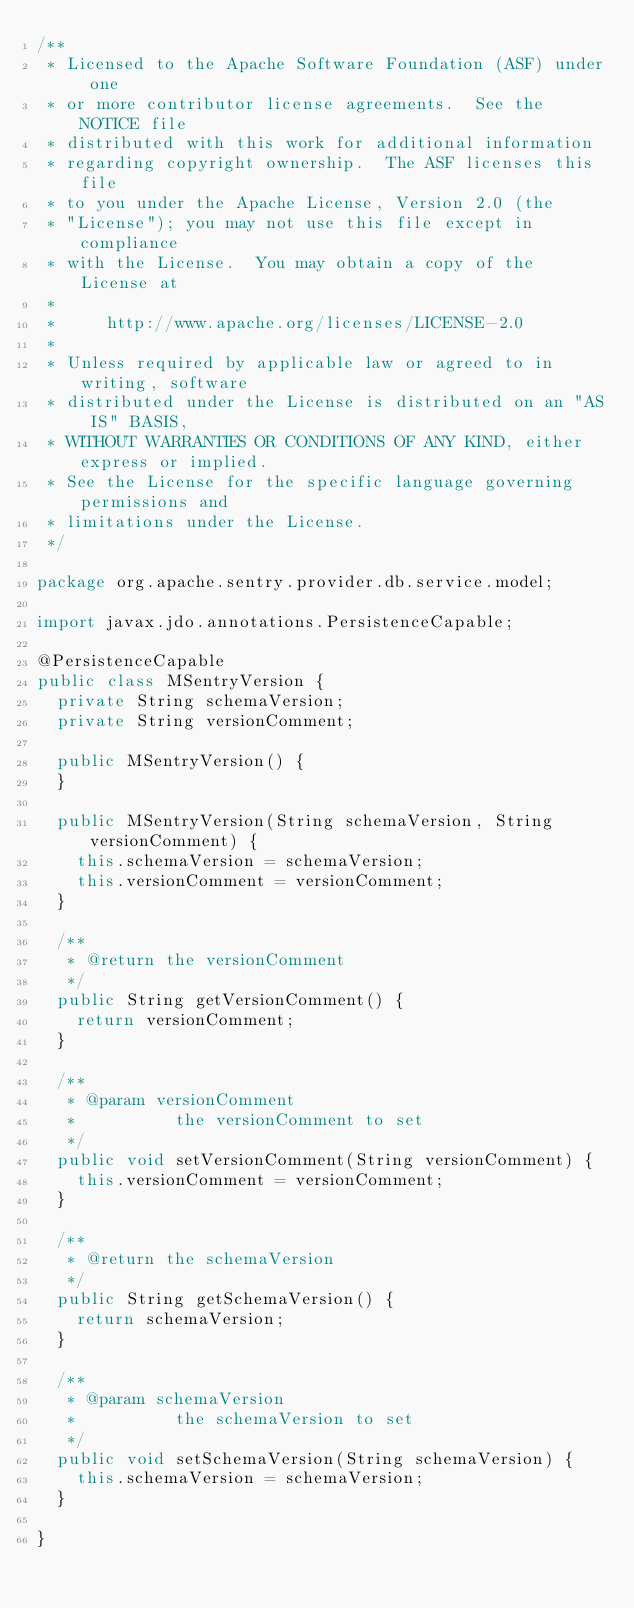<code> <loc_0><loc_0><loc_500><loc_500><_Java_>/**
 * Licensed to the Apache Software Foundation (ASF) under one
 * or more contributor license agreements.  See the NOTICE file
 * distributed with this work for additional information
 * regarding copyright ownership.  The ASF licenses this file
 * to you under the Apache License, Version 2.0 (the
 * "License"); you may not use this file except in compliance
 * with the License.  You may obtain a copy of the License at
 *
 *     http://www.apache.org/licenses/LICENSE-2.0
 *
 * Unless required by applicable law or agreed to in writing, software
 * distributed under the License is distributed on an "AS IS" BASIS,
 * WITHOUT WARRANTIES OR CONDITIONS OF ANY KIND, either express or implied.
 * See the License for the specific language governing permissions and
 * limitations under the License.
 */

package org.apache.sentry.provider.db.service.model;

import javax.jdo.annotations.PersistenceCapable;

@PersistenceCapable
public class MSentryVersion {
  private String schemaVersion;
  private String versionComment;

  public MSentryVersion() {
  }

  public MSentryVersion(String schemaVersion, String versionComment) {
    this.schemaVersion = schemaVersion;
    this.versionComment = versionComment;
  }

  /**
   * @return the versionComment
   */
  public String getVersionComment() {
    return versionComment;
  }

  /**
   * @param versionComment
   *          the versionComment to set
   */
  public void setVersionComment(String versionComment) {
    this.versionComment = versionComment;
  }

  /**
   * @return the schemaVersion
   */
  public String getSchemaVersion() {
    return schemaVersion;
  }

  /**
   * @param schemaVersion
   *          the schemaVersion to set
   */
  public void setSchemaVersion(String schemaVersion) {
    this.schemaVersion = schemaVersion;
  }

}
</code> 